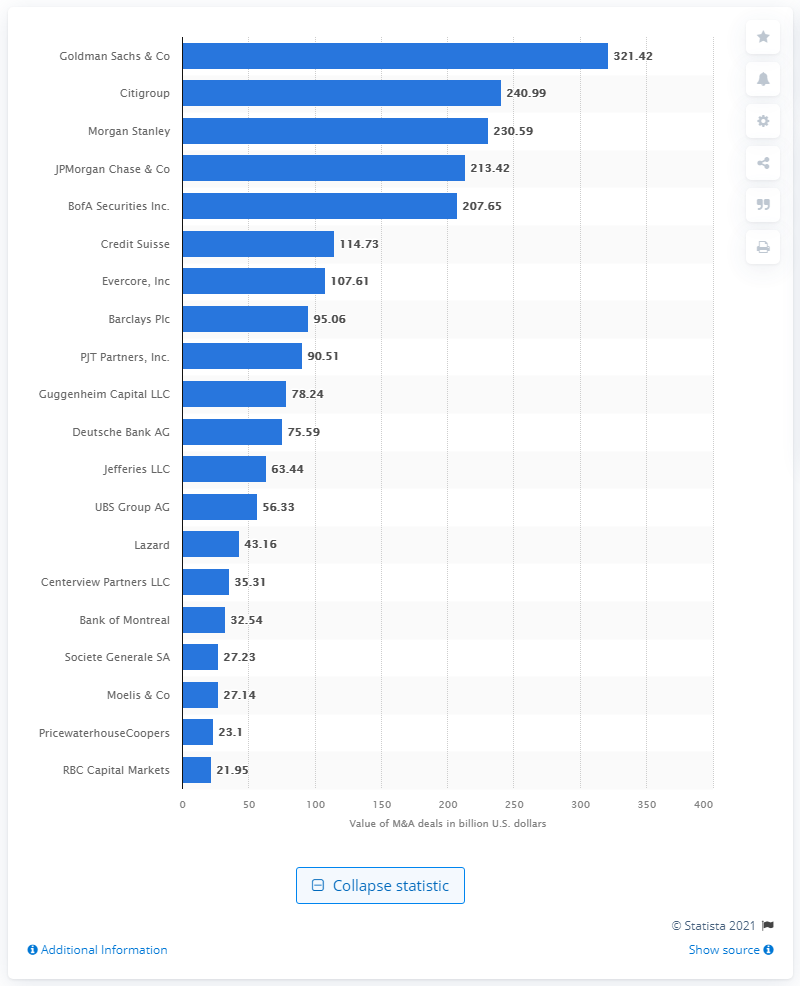Highlight a few significant elements in this photo. Goldman Sachs advised on a total of 321.42 deals in the first quarter of 2021. 